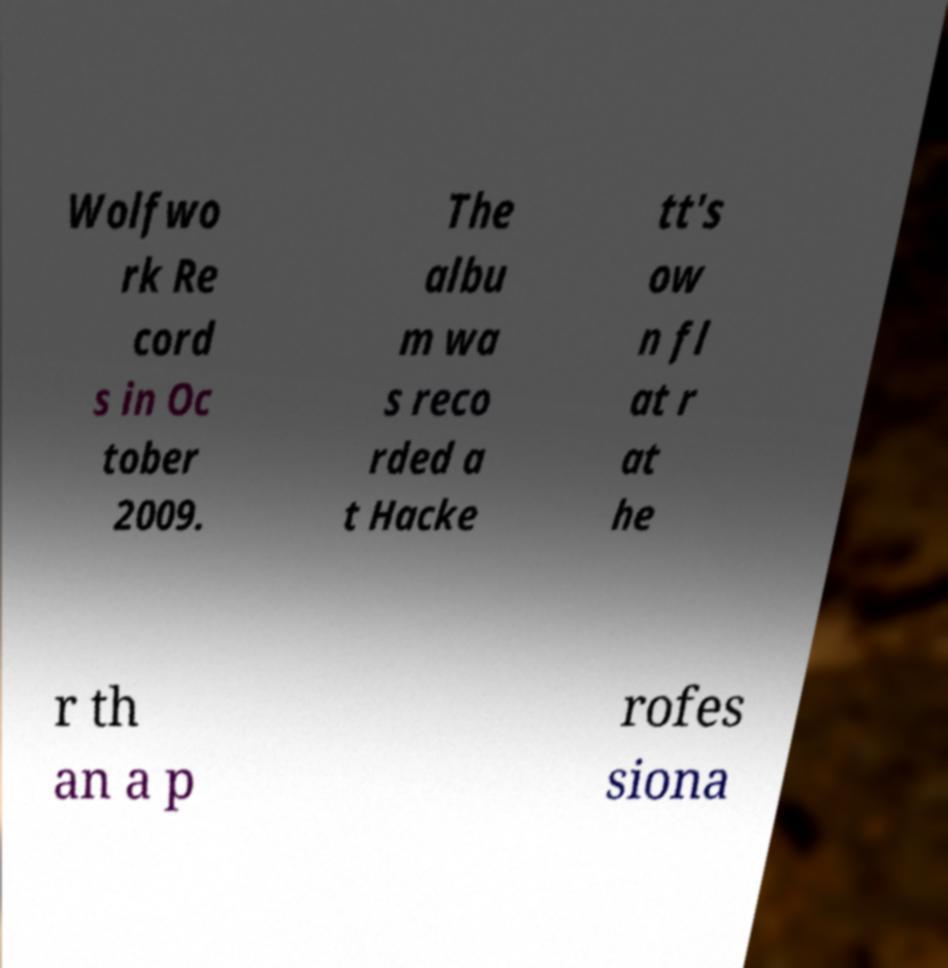Please identify and transcribe the text found in this image. Wolfwo rk Re cord s in Oc tober 2009. The albu m wa s reco rded a t Hacke tt's ow n fl at r at he r th an a p rofes siona 